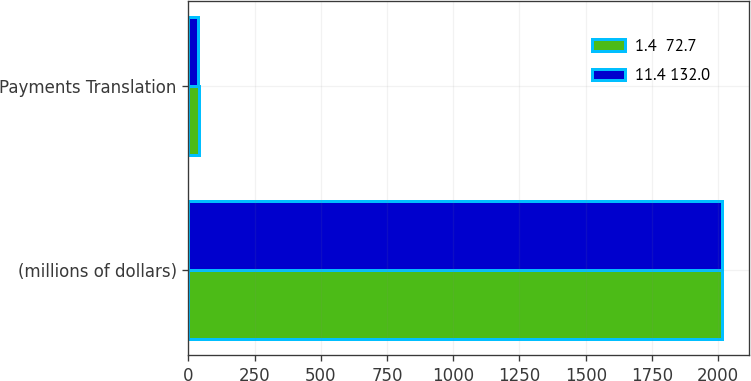Convert chart. <chart><loc_0><loc_0><loc_500><loc_500><stacked_bar_chart><ecel><fcel>(millions of dollars)<fcel>Payments Translation<nl><fcel>1.4  72.7<fcel>2014<fcel>42<nl><fcel>11.4 132.0<fcel>2013<fcel>36.7<nl></chart> 